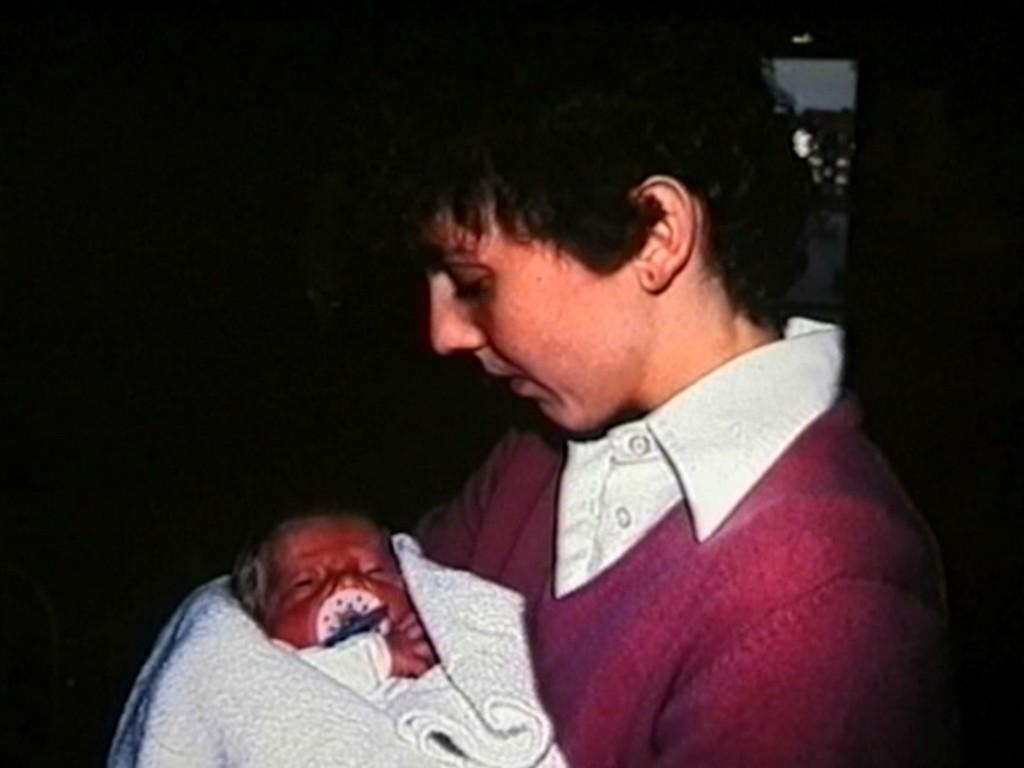Who is the main subject in the image? There is a boy in the image. What is the boy wearing? The boy is wearing a red sweater and a white shirt. What is the boy doing in the image? The boy is holding a baby in his arms. What type of cough medicine is the boy holding in the image? There is no cough medicine present in the image; the boy is holding a baby in his arms. 